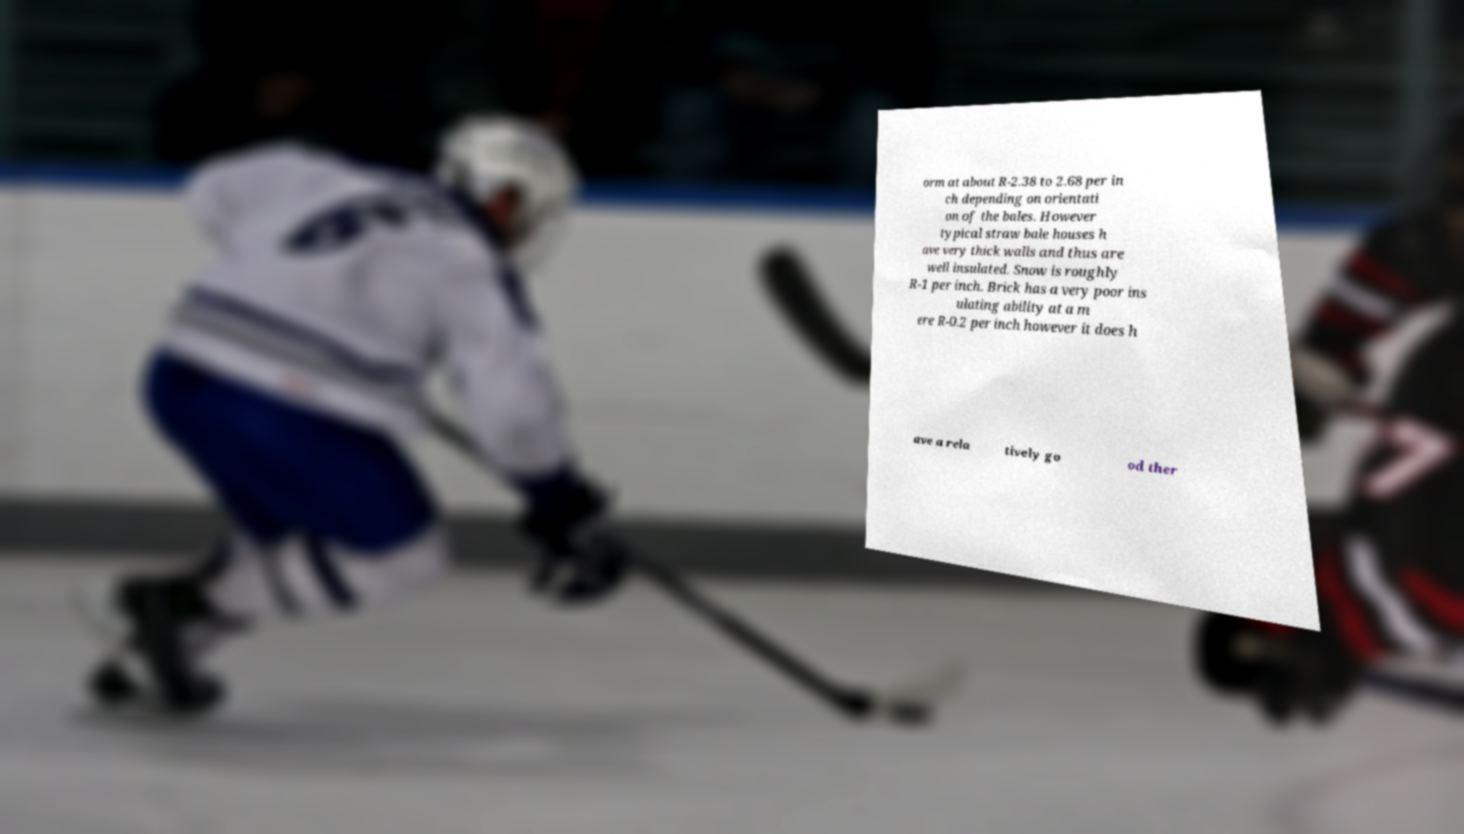Could you extract and type out the text from this image? orm at about R-2.38 to 2.68 per in ch depending on orientati on of the bales. However typical straw bale houses h ave very thick walls and thus are well insulated. Snow is roughly R-1 per inch. Brick has a very poor ins ulating ability at a m ere R-0.2 per inch however it does h ave a rela tively go od ther 